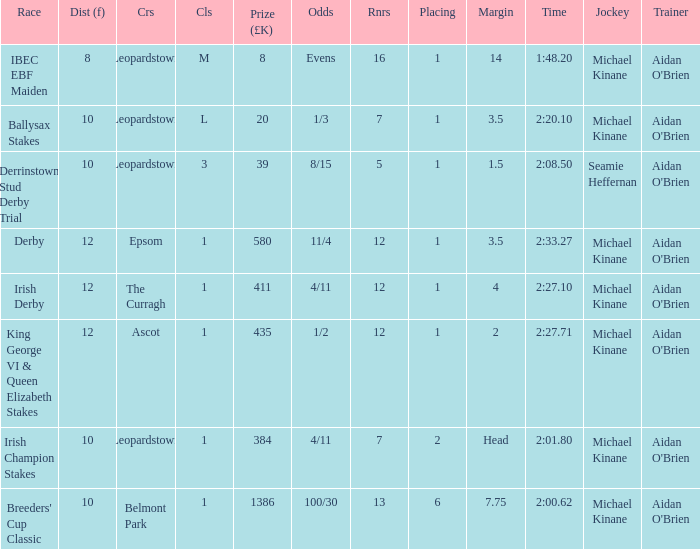Which Class has a Jockey of michael kinane on 2:27.71? 1.0. 